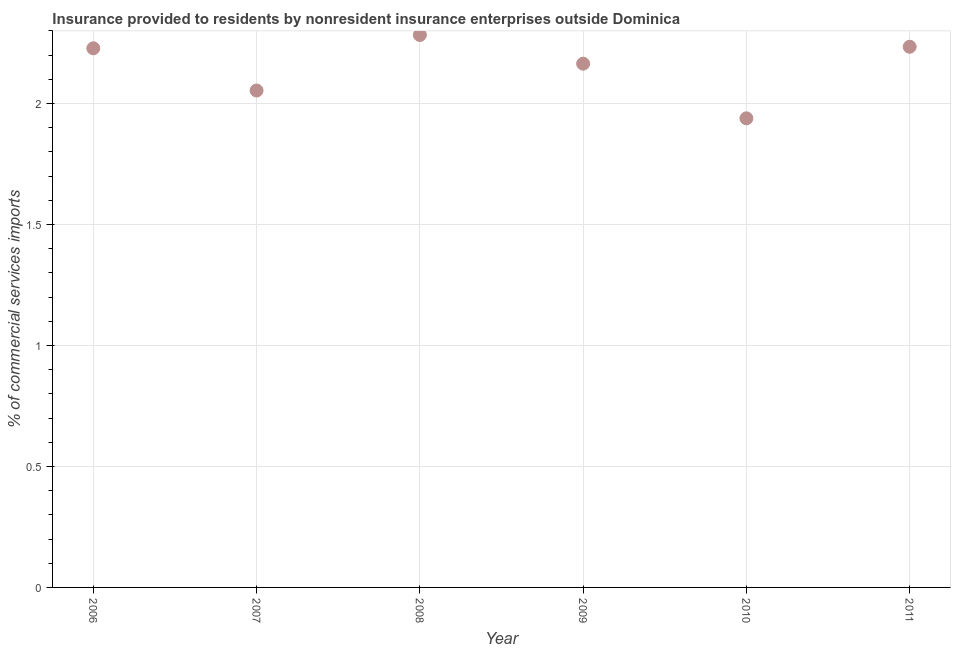What is the insurance provided by non-residents in 2009?
Your answer should be very brief. 2.16. Across all years, what is the maximum insurance provided by non-residents?
Give a very brief answer. 2.28. Across all years, what is the minimum insurance provided by non-residents?
Provide a succinct answer. 1.94. In which year was the insurance provided by non-residents minimum?
Give a very brief answer. 2010. What is the sum of the insurance provided by non-residents?
Offer a terse response. 12.9. What is the difference between the insurance provided by non-residents in 2008 and 2011?
Your answer should be very brief. 0.05. What is the average insurance provided by non-residents per year?
Keep it short and to the point. 2.15. What is the median insurance provided by non-residents?
Your answer should be very brief. 2.2. What is the ratio of the insurance provided by non-residents in 2009 to that in 2010?
Keep it short and to the point. 1.12. Is the insurance provided by non-residents in 2007 less than that in 2008?
Provide a short and direct response. Yes. Is the difference between the insurance provided by non-residents in 2006 and 2009 greater than the difference between any two years?
Your answer should be very brief. No. What is the difference between the highest and the second highest insurance provided by non-residents?
Your response must be concise. 0.05. What is the difference between the highest and the lowest insurance provided by non-residents?
Provide a short and direct response. 0.34. In how many years, is the insurance provided by non-residents greater than the average insurance provided by non-residents taken over all years?
Provide a short and direct response. 4. Does the insurance provided by non-residents monotonically increase over the years?
Your answer should be very brief. No. How many dotlines are there?
Offer a very short reply. 1. How many years are there in the graph?
Make the answer very short. 6. What is the difference between two consecutive major ticks on the Y-axis?
Provide a succinct answer. 0.5. Are the values on the major ticks of Y-axis written in scientific E-notation?
Your answer should be compact. No. What is the title of the graph?
Your answer should be very brief. Insurance provided to residents by nonresident insurance enterprises outside Dominica. What is the label or title of the X-axis?
Ensure brevity in your answer.  Year. What is the label or title of the Y-axis?
Your answer should be compact. % of commercial services imports. What is the % of commercial services imports in 2006?
Ensure brevity in your answer.  2.23. What is the % of commercial services imports in 2007?
Make the answer very short. 2.05. What is the % of commercial services imports in 2008?
Offer a very short reply. 2.28. What is the % of commercial services imports in 2009?
Your response must be concise. 2.16. What is the % of commercial services imports in 2010?
Give a very brief answer. 1.94. What is the % of commercial services imports in 2011?
Your response must be concise. 2.23. What is the difference between the % of commercial services imports in 2006 and 2007?
Give a very brief answer. 0.17. What is the difference between the % of commercial services imports in 2006 and 2008?
Ensure brevity in your answer.  -0.05. What is the difference between the % of commercial services imports in 2006 and 2009?
Give a very brief answer. 0.06. What is the difference between the % of commercial services imports in 2006 and 2010?
Your response must be concise. 0.29. What is the difference between the % of commercial services imports in 2006 and 2011?
Your response must be concise. -0.01. What is the difference between the % of commercial services imports in 2007 and 2008?
Give a very brief answer. -0.23. What is the difference between the % of commercial services imports in 2007 and 2009?
Make the answer very short. -0.11. What is the difference between the % of commercial services imports in 2007 and 2010?
Provide a succinct answer. 0.11. What is the difference between the % of commercial services imports in 2007 and 2011?
Your answer should be very brief. -0.18. What is the difference between the % of commercial services imports in 2008 and 2009?
Provide a succinct answer. 0.12. What is the difference between the % of commercial services imports in 2008 and 2010?
Your answer should be very brief. 0.34. What is the difference between the % of commercial services imports in 2008 and 2011?
Give a very brief answer. 0.05. What is the difference between the % of commercial services imports in 2009 and 2010?
Give a very brief answer. 0.23. What is the difference between the % of commercial services imports in 2009 and 2011?
Your answer should be compact. -0.07. What is the difference between the % of commercial services imports in 2010 and 2011?
Provide a short and direct response. -0.3. What is the ratio of the % of commercial services imports in 2006 to that in 2007?
Provide a short and direct response. 1.08. What is the ratio of the % of commercial services imports in 2006 to that in 2008?
Provide a short and direct response. 0.98. What is the ratio of the % of commercial services imports in 2006 to that in 2009?
Your response must be concise. 1.03. What is the ratio of the % of commercial services imports in 2006 to that in 2010?
Your answer should be very brief. 1.15. What is the ratio of the % of commercial services imports in 2007 to that in 2008?
Make the answer very short. 0.9. What is the ratio of the % of commercial services imports in 2007 to that in 2009?
Offer a terse response. 0.95. What is the ratio of the % of commercial services imports in 2007 to that in 2010?
Make the answer very short. 1.06. What is the ratio of the % of commercial services imports in 2007 to that in 2011?
Offer a terse response. 0.92. What is the ratio of the % of commercial services imports in 2008 to that in 2009?
Your answer should be compact. 1.05. What is the ratio of the % of commercial services imports in 2008 to that in 2010?
Keep it short and to the point. 1.18. What is the ratio of the % of commercial services imports in 2009 to that in 2010?
Keep it short and to the point. 1.12. What is the ratio of the % of commercial services imports in 2009 to that in 2011?
Your answer should be very brief. 0.97. What is the ratio of the % of commercial services imports in 2010 to that in 2011?
Offer a very short reply. 0.87. 